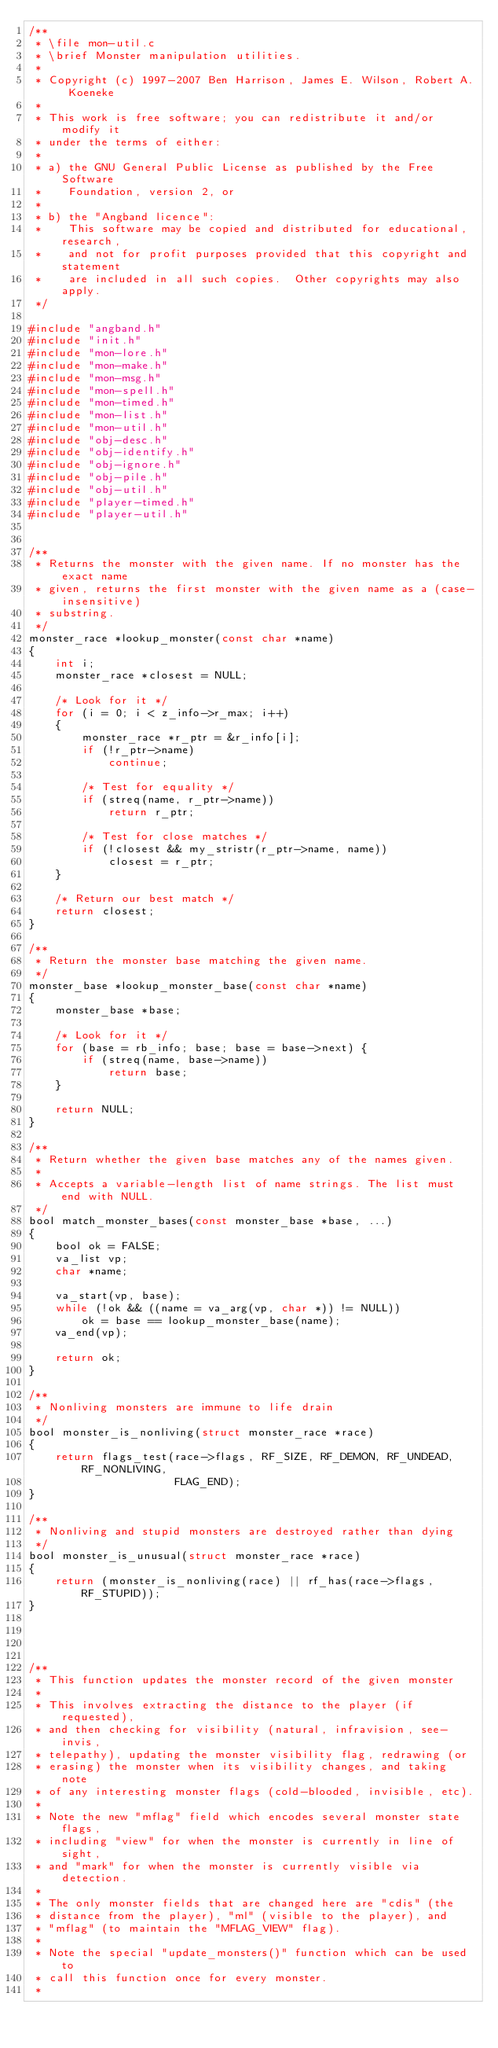Convert code to text. <code><loc_0><loc_0><loc_500><loc_500><_C_>/**
 * \file mon-util.c
 * \brief Monster manipulation utilities.
 *
 * Copyright (c) 1997-2007 Ben Harrison, James E. Wilson, Robert A. Koeneke
 *
 * This work is free software; you can redistribute it and/or modify it
 * under the terms of either:
 *
 * a) the GNU General Public License as published by the Free Software
 *    Foundation, version 2, or
 *
 * b) the "Angband licence":
 *    This software may be copied and distributed for educational, research,
 *    and not for profit purposes provided that this copyright and statement
 *    are included in all such copies.  Other copyrights may also apply.
 */

#include "angband.h"
#include "init.h"
#include "mon-lore.h"
#include "mon-make.h"
#include "mon-msg.h"
#include "mon-spell.h"
#include "mon-timed.h"
#include "mon-list.h"
#include "mon-util.h"
#include "obj-desc.h"
#include "obj-identify.h"
#include "obj-ignore.h"
#include "obj-pile.h"
#include "obj-util.h"
#include "player-timed.h"
#include "player-util.h"


/**
 * Returns the monster with the given name. If no monster has the exact name
 * given, returns the first monster with the given name as a (case-insensitive)
 * substring.
 */
monster_race *lookup_monster(const char *name)
{
	int i;
	monster_race *closest = NULL;
	
	/* Look for it */
	for (i = 0; i < z_info->r_max; i++)
	{
		monster_race *r_ptr = &r_info[i];
		if (!r_ptr->name)
			continue;

		/* Test for equality */
		if (streq(name, r_ptr->name))
			return r_ptr;

		/* Test for close matches */
		if (!closest && my_stristr(r_ptr->name, name))
			closest = r_ptr;
	} 

	/* Return our best match */
	return closest;
}

/**
 * Return the monster base matching the given name.
 */
monster_base *lookup_monster_base(const char *name)
{
	monster_base *base;

	/* Look for it */
	for (base = rb_info; base; base = base->next) {
		if (streq(name, base->name))
			return base;
	}

	return NULL;
}

/**
 * Return whether the given base matches any of the names given.
 *
 * Accepts a variable-length list of name strings. The list must end with NULL.
 */
bool match_monster_bases(const monster_base *base, ...)
{
	bool ok = FALSE;
	va_list vp;
	char *name;

	va_start(vp, base);
	while (!ok && ((name = va_arg(vp, char *)) != NULL))
		ok = base == lookup_monster_base(name);
	va_end(vp);

	return ok;
}

/**
 * Nonliving monsters are immune to life drain
 */
bool monster_is_nonliving(struct monster_race *race)
{
	return flags_test(race->flags, RF_SIZE, RF_DEMON, RF_UNDEAD, RF_NONLIVING,
					  FLAG_END);
}

/**
 * Nonliving and stupid monsters are destroyed rather than dying
 */
bool monster_is_unusual(struct monster_race *race)
{
	return (monster_is_nonliving(race) || rf_has(race->flags, RF_STUPID));
}




/**
 * This function updates the monster record of the given monster
 *
 * This involves extracting the distance to the player (if requested),
 * and then checking for visibility (natural, infravision, see-invis,
 * telepathy), updating the monster visibility flag, redrawing (or
 * erasing) the monster when its visibility changes, and taking note
 * of any interesting monster flags (cold-blooded, invisible, etc).
 *
 * Note the new "mflag" field which encodes several monster state flags,
 * including "view" for when the monster is currently in line of sight,
 * and "mark" for when the monster is currently visible via detection.
 *
 * The only monster fields that are changed here are "cdis" (the
 * distance from the player), "ml" (visible to the player), and
 * "mflag" (to maintain the "MFLAG_VIEW" flag).
 *
 * Note the special "update_monsters()" function which can be used to
 * call this function once for every monster.
 *</code> 